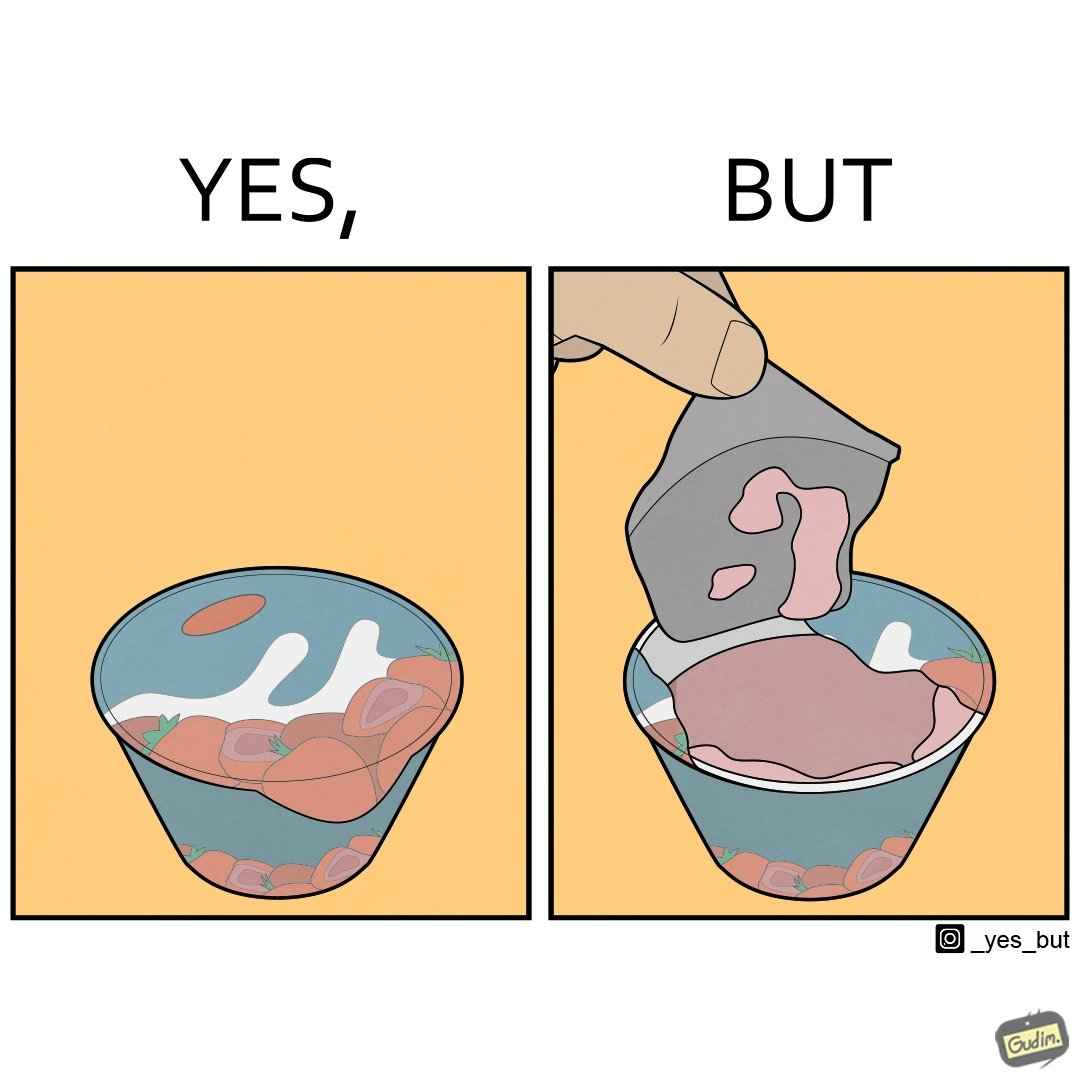Is this image satirical or non-satirical? Yes, this image is satirical. 